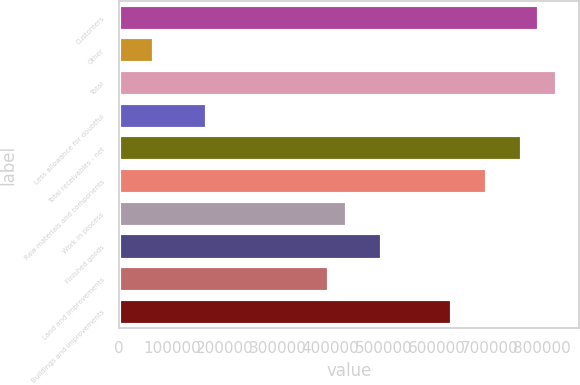<chart> <loc_0><loc_0><loc_500><loc_500><bar_chart><fcel>Customers<fcel>Other<fcel>Total<fcel>Less allowance for doubtful<fcel>Total receivables - net<fcel>Raw materials and components<fcel>Work in process<fcel>Finished goods<fcel>Land and improvements<fcel>Buildings and improvements<nl><fcel>794431<fcel>67175.2<fcel>827488<fcel>166346<fcel>761374<fcel>695260<fcel>430803<fcel>496918<fcel>397746<fcel>629146<nl></chart> 